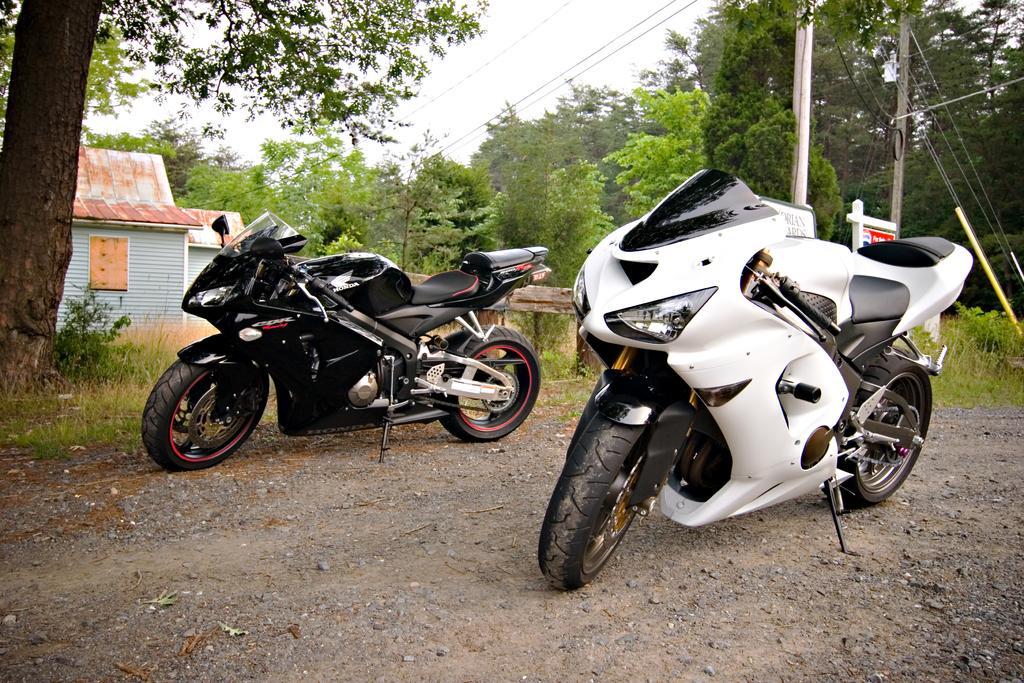Describe this image in one or two sentences. In this image I can see two motorbikes on the ground. To the side of these motor bikes I can see many trees, poles, boards and the house. I can also see the sky in the back. 